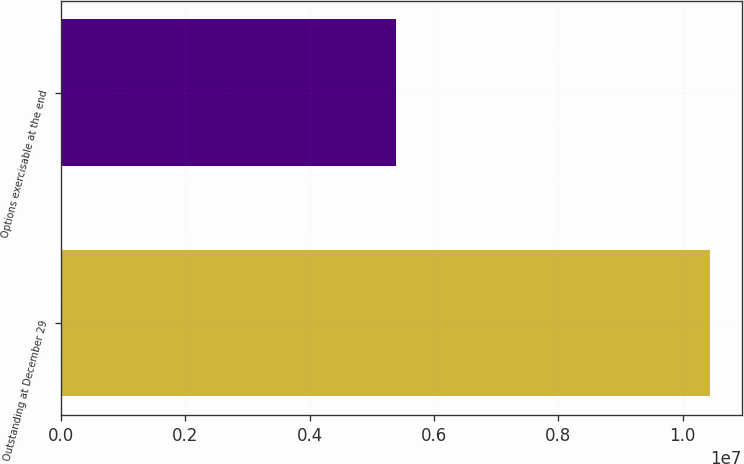<chart> <loc_0><loc_0><loc_500><loc_500><bar_chart><fcel>Outstanding at December 29<fcel>Options exercisable at the end<nl><fcel>1.04324e+07<fcel>5.39175e+06<nl></chart> 